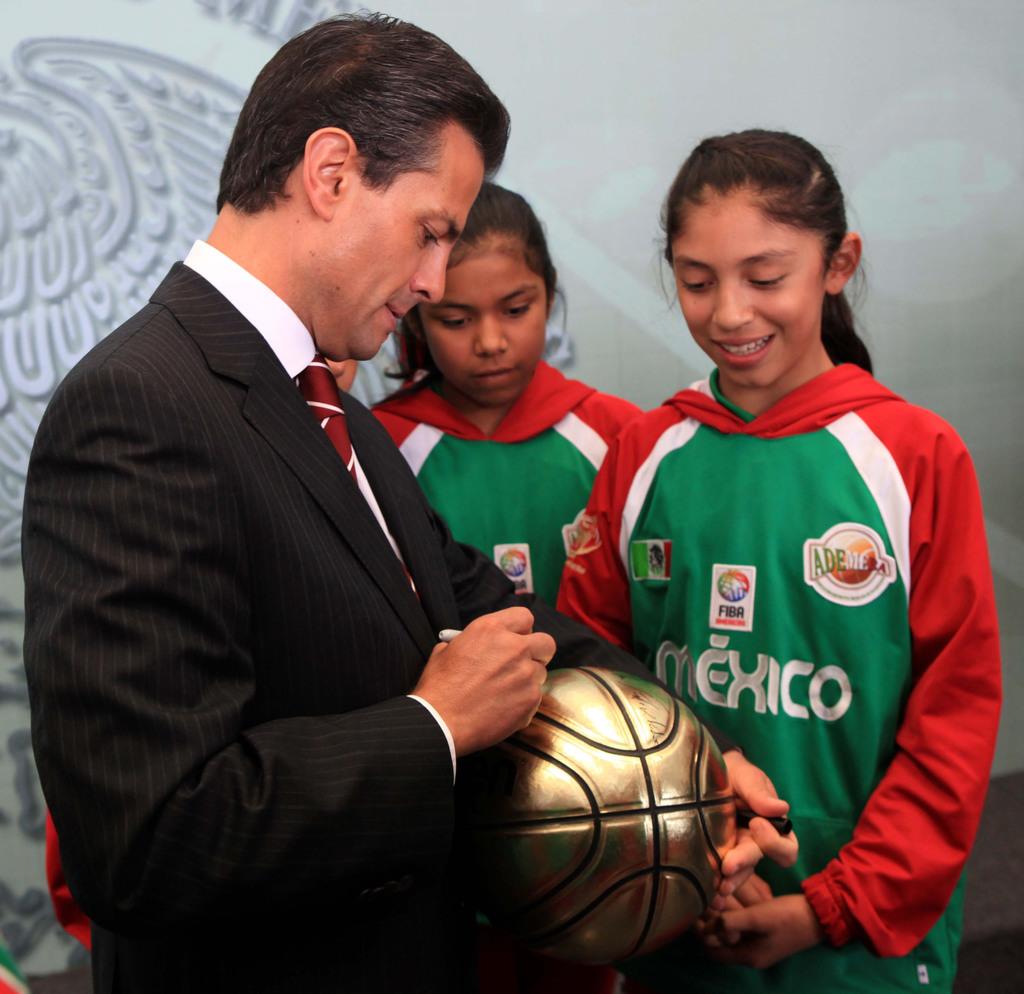What is the soccer league on the jersey?
Give a very brief answer. Mexico. 